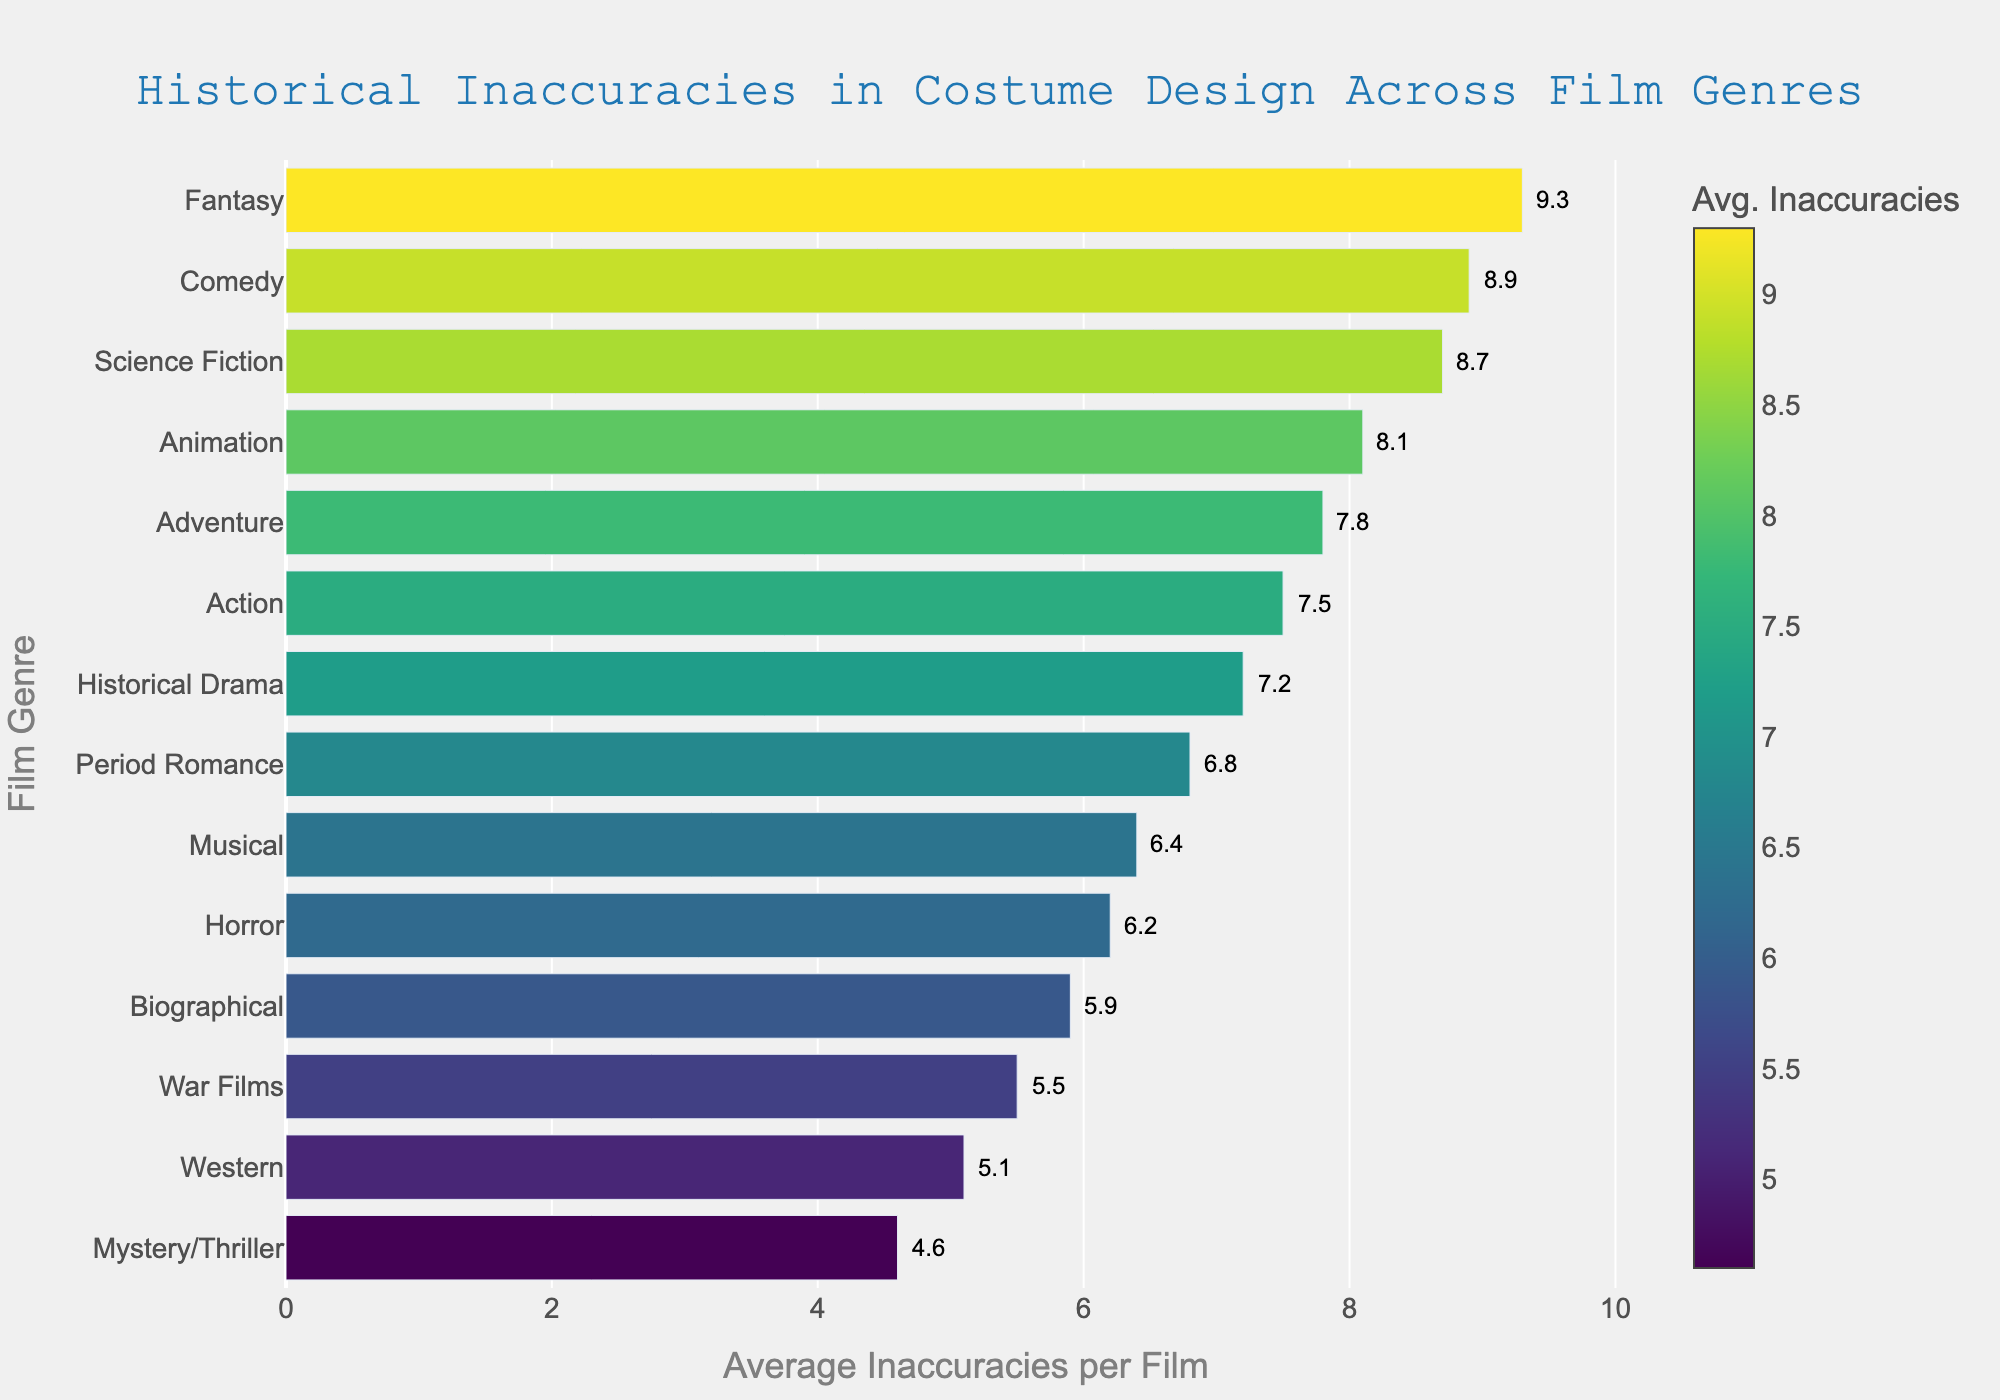Which film genre has the highest average number of historical inaccuracies per film? The bar chart shows that Fantasy has the highest average number of historical inaccuracies per film with a value of 9.3. The longest bar in the chart is associated with the Fantasy genre, indicating the highest value.
Answer: Fantasy Which film genre has fewer average inaccuracies: War Films or Western? According to the chart, War Films have an average inaccuracy of 5.5, whereas Western has an average of 5.1. Since 5.1 is less than 5.5, Western has fewer average inaccuracies.
Answer: Western Compare the average inaccuracies per film in Historical Drama and Comedy genres. Which has more inaccuracies and by how much? The bar chart indicates that Historical Drama has an average inaccuracy of 7.2, while Comedy has 8.9. The difference between them is 8.9 - 7.2 = 1.7, so Comedy has more inaccuracies by 1.7.
Answer: Comedy by 1.7 What is the difference between the average inaccuracies in Animation and Science Fiction genres? Animation has an average inaccuracy of 8.1, while Science Fiction has 8.7. The difference is calculated as 8.7 - 8.1 = 0.6.
Answer: 0.6 What is the average number of inaccuracies for genres that are neither the highest nor the lowest in terms of inaccuracies? First, remove the highest (Fantasy, 9.3) and the lowest (Mystery/Thriller, 4.6). The remaining values are [8.9, 8.7, 8.1, 7.8, 7.5, 7.2, 6.8, 6.4, 6.2, 5.9, 5.5, 5.1]. The average = (8.9+8.7+8.1+7.8+7.5+7.2+6.8+6.4+6.2+5.9+5.5+5.1)/12 = 86.1/12 ≈ 7.175.
Answer: ~7.2 Identify the color intensity pattern along the bars as they represent the average inaccuracies across genres. How does the color change with the inaccuracies? The color intensifies from lighter to darker shades as the average inaccuracies increase. Bars representing higher inaccuracies have a darker tone, whereas bars with fewer inaccuracies are lighter. For example, the bar for Comedy at 8.9 is darker than the bar for Western at 5.1.
Answer: Darker with more inaccuracies Which genre has just above 7 average inaccuracies in costume design? The Historical Drama genre has just above 7 average inaccuracies, with a specific value of 7.2. This is evident from the bar label and its visual placement just above 7 on the x-axis.
Answer: Historical Drama 